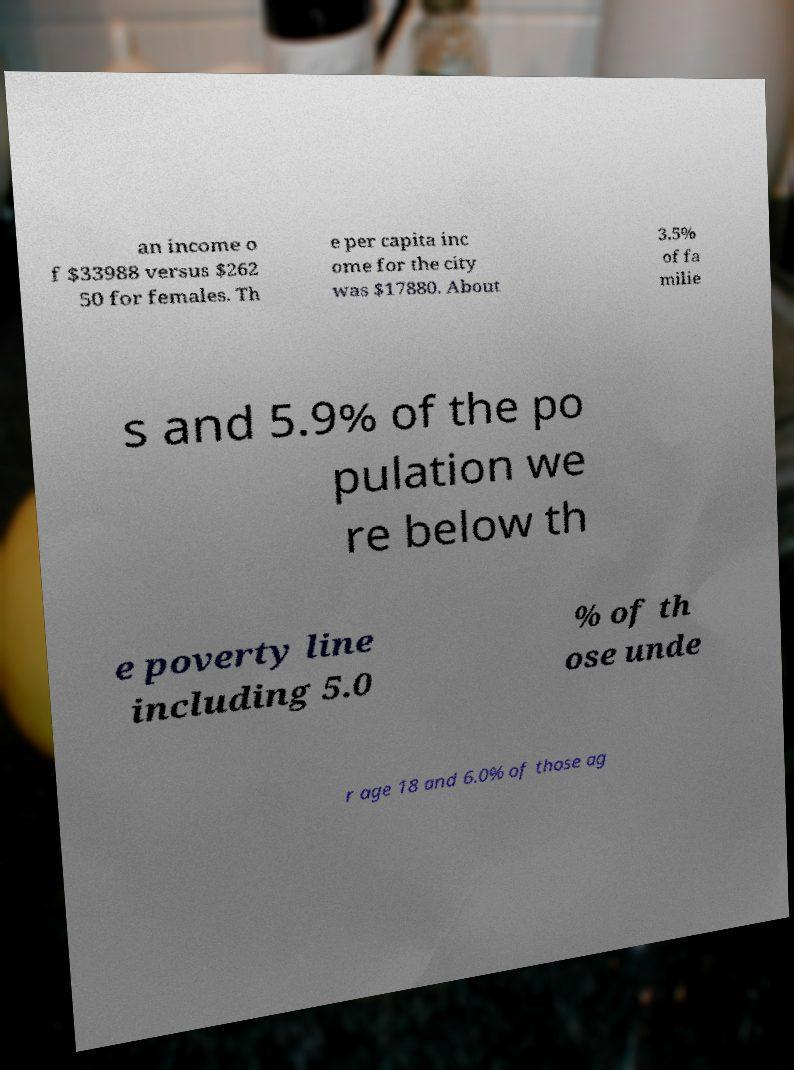Can you accurately transcribe the text from the provided image for me? an income o f $33988 versus $262 50 for females. Th e per capita inc ome for the city was $17880. About 3.5% of fa milie s and 5.9% of the po pulation we re below th e poverty line including 5.0 % of th ose unde r age 18 and 6.0% of those ag 